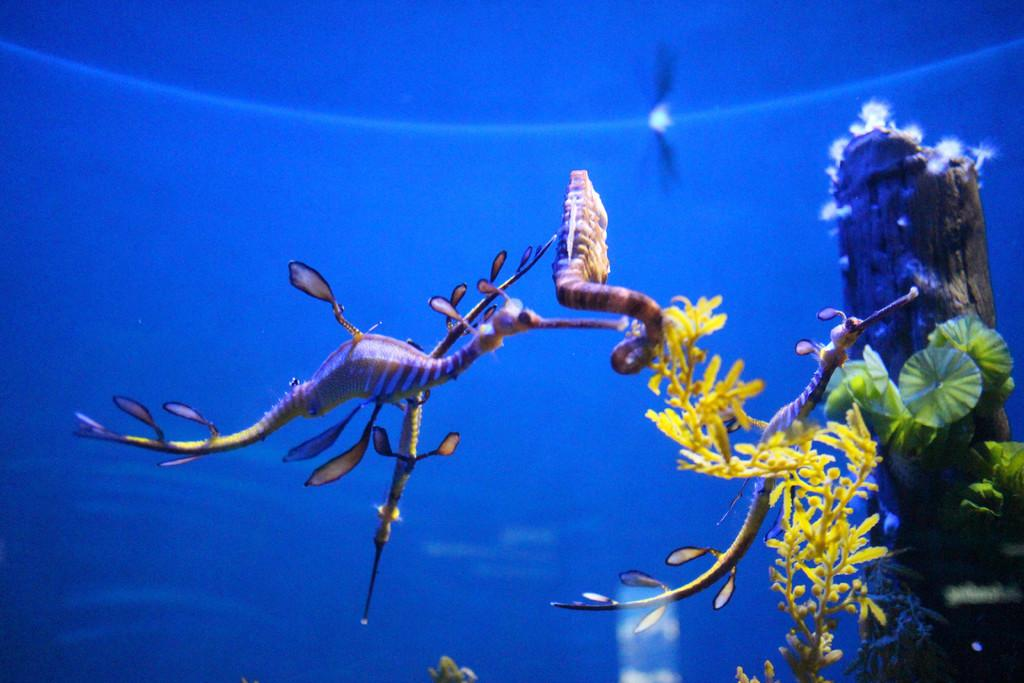What type of animals can be seen in the water in the image? There are seahorses in the water in the image. What else can be seen in the water besides the seahorses? There are plants and a wooden block in the water. Can you describe the location of the wooden block in the image? The wooden block is on the right side in the image. What type of knot is being used to tie the eggs together in the image? There are no knots or eggs present in the image; it features seahorses, plants, and a wooden block in the water. 